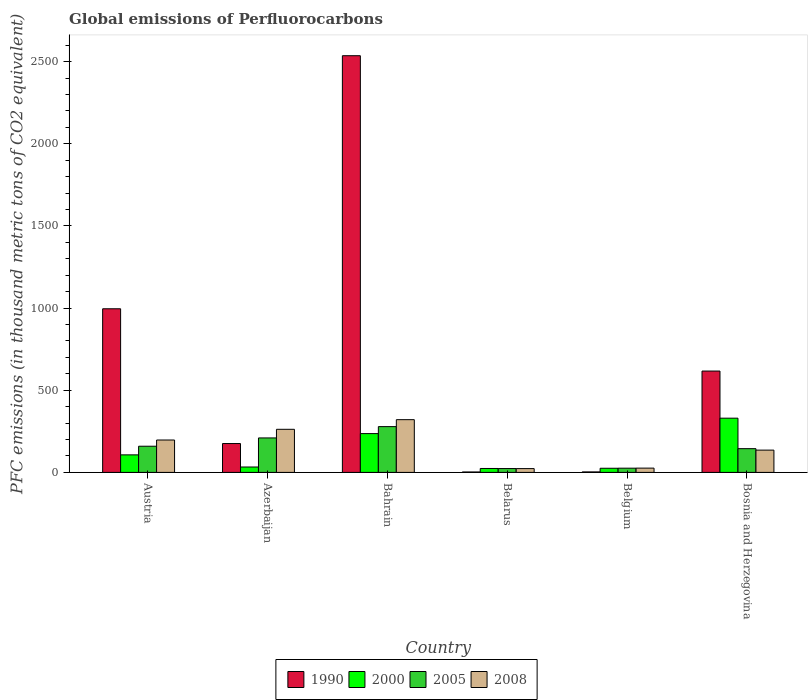How many different coloured bars are there?
Your answer should be compact. 4. How many groups of bars are there?
Offer a very short reply. 6. Are the number of bars per tick equal to the number of legend labels?
Your answer should be very brief. Yes. Are the number of bars on each tick of the X-axis equal?
Provide a short and direct response. Yes. How many bars are there on the 5th tick from the left?
Provide a short and direct response. 4. How many bars are there on the 1st tick from the right?
Ensure brevity in your answer.  4. What is the global emissions of Perfluorocarbons in 1990 in Azerbaijan?
Your answer should be compact. 175.6. Across all countries, what is the maximum global emissions of Perfluorocarbons in 1990?
Your response must be concise. 2535.7. Across all countries, what is the minimum global emissions of Perfluorocarbons in 2000?
Ensure brevity in your answer.  23.9. In which country was the global emissions of Perfluorocarbons in 1990 maximum?
Offer a very short reply. Bahrain. In which country was the global emissions of Perfluorocarbons in 1990 minimum?
Make the answer very short. Belarus. What is the total global emissions of Perfluorocarbons in 2005 in the graph?
Ensure brevity in your answer.  841.1. What is the difference between the global emissions of Perfluorocarbons in 2000 in Azerbaijan and that in Belarus?
Your answer should be compact. 8.9. What is the difference between the global emissions of Perfluorocarbons in 2008 in Belgium and the global emissions of Perfluorocarbons in 2005 in Azerbaijan?
Keep it short and to the point. -183.7. What is the average global emissions of Perfluorocarbons in 2005 per country?
Your answer should be very brief. 140.18. What is the difference between the global emissions of Perfluorocarbons of/in 2005 and global emissions of Perfluorocarbons of/in 1990 in Bosnia and Herzegovina?
Offer a terse response. -472.3. In how many countries, is the global emissions of Perfluorocarbons in 2005 greater than 1700 thousand metric tons?
Offer a very short reply. 0. What is the ratio of the global emissions of Perfluorocarbons in 2008 in Belarus to that in Belgium?
Give a very brief answer. 0.89. Is the global emissions of Perfluorocarbons in 2008 in Bahrain less than that in Belarus?
Ensure brevity in your answer.  No. What is the difference between the highest and the second highest global emissions of Perfluorocarbons in 2000?
Provide a short and direct response. 223.2. What is the difference between the highest and the lowest global emissions of Perfluorocarbons in 1990?
Your response must be concise. 2533.1. In how many countries, is the global emissions of Perfluorocarbons in 1990 greater than the average global emissions of Perfluorocarbons in 1990 taken over all countries?
Offer a terse response. 2. Is the sum of the global emissions of Perfluorocarbons in 2005 in Azerbaijan and Belgium greater than the maximum global emissions of Perfluorocarbons in 2008 across all countries?
Provide a short and direct response. No. Is it the case that in every country, the sum of the global emissions of Perfluorocarbons in 2008 and global emissions of Perfluorocarbons in 1990 is greater than the sum of global emissions of Perfluorocarbons in 2000 and global emissions of Perfluorocarbons in 2005?
Give a very brief answer. No. What does the 3rd bar from the left in Belgium represents?
Offer a very short reply. 2005. Are all the bars in the graph horizontal?
Your answer should be compact. No. What is the difference between two consecutive major ticks on the Y-axis?
Ensure brevity in your answer.  500. Are the values on the major ticks of Y-axis written in scientific E-notation?
Your answer should be compact. No. Does the graph contain grids?
Ensure brevity in your answer.  No. How many legend labels are there?
Your response must be concise. 4. How are the legend labels stacked?
Your answer should be very brief. Horizontal. What is the title of the graph?
Provide a short and direct response. Global emissions of Perfluorocarbons. Does "2013" appear as one of the legend labels in the graph?
Provide a succinct answer. No. What is the label or title of the Y-axis?
Ensure brevity in your answer.  PFC emissions (in thousand metric tons of CO2 equivalent). What is the PFC emissions (in thousand metric tons of CO2 equivalent) of 1990 in Austria?
Offer a terse response. 995.7. What is the PFC emissions (in thousand metric tons of CO2 equivalent) in 2000 in Austria?
Offer a very short reply. 106.7. What is the PFC emissions (in thousand metric tons of CO2 equivalent) of 2005 in Austria?
Provide a succinct answer. 159.3. What is the PFC emissions (in thousand metric tons of CO2 equivalent) in 2008 in Austria?
Your answer should be very brief. 197.1. What is the PFC emissions (in thousand metric tons of CO2 equivalent) of 1990 in Azerbaijan?
Provide a short and direct response. 175.6. What is the PFC emissions (in thousand metric tons of CO2 equivalent) of 2000 in Azerbaijan?
Keep it short and to the point. 32.8. What is the PFC emissions (in thousand metric tons of CO2 equivalent) of 2005 in Azerbaijan?
Offer a very short reply. 209.7. What is the PFC emissions (in thousand metric tons of CO2 equivalent) in 2008 in Azerbaijan?
Your answer should be very brief. 262.2. What is the PFC emissions (in thousand metric tons of CO2 equivalent) in 1990 in Bahrain?
Ensure brevity in your answer.  2535.7. What is the PFC emissions (in thousand metric tons of CO2 equivalent) in 2000 in Bahrain?
Keep it short and to the point. 236.1. What is the PFC emissions (in thousand metric tons of CO2 equivalent) in 2005 in Bahrain?
Give a very brief answer. 278.6. What is the PFC emissions (in thousand metric tons of CO2 equivalent) in 2008 in Bahrain?
Your answer should be compact. 320.9. What is the PFC emissions (in thousand metric tons of CO2 equivalent) of 1990 in Belarus?
Your response must be concise. 2.6. What is the PFC emissions (in thousand metric tons of CO2 equivalent) in 2000 in Belarus?
Your response must be concise. 23.9. What is the PFC emissions (in thousand metric tons of CO2 equivalent) of 2005 in Belarus?
Provide a succinct answer. 23.4. What is the PFC emissions (in thousand metric tons of CO2 equivalent) of 2008 in Belarus?
Your answer should be compact. 23.1. What is the PFC emissions (in thousand metric tons of CO2 equivalent) in 2000 in Belgium?
Your response must be concise. 25.2. What is the PFC emissions (in thousand metric tons of CO2 equivalent) in 2005 in Belgium?
Offer a terse response. 25.7. What is the PFC emissions (in thousand metric tons of CO2 equivalent) of 2008 in Belgium?
Offer a terse response. 26. What is the PFC emissions (in thousand metric tons of CO2 equivalent) in 1990 in Bosnia and Herzegovina?
Your response must be concise. 616.7. What is the PFC emissions (in thousand metric tons of CO2 equivalent) in 2000 in Bosnia and Herzegovina?
Keep it short and to the point. 329.9. What is the PFC emissions (in thousand metric tons of CO2 equivalent) of 2005 in Bosnia and Herzegovina?
Your response must be concise. 144.4. What is the PFC emissions (in thousand metric tons of CO2 equivalent) in 2008 in Bosnia and Herzegovina?
Make the answer very short. 135.6. Across all countries, what is the maximum PFC emissions (in thousand metric tons of CO2 equivalent) of 1990?
Ensure brevity in your answer.  2535.7. Across all countries, what is the maximum PFC emissions (in thousand metric tons of CO2 equivalent) of 2000?
Keep it short and to the point. 329.9. Across all countries, what is the maximum PFC emissions (in thousand metric tons of CO2 equivalent) of 2005?
Your answer should be very brief. 278.6. Across all countries, what is the maximum PFC emissions (in thousand metric tons of CO2 equivalent) of 2008?
Your answer should be very brief. 320.9. Across all countries, what is the minimum PFC emissions (in thousand metric tons of CO2 equivalent) of 2000?
Provide a succinct answer. 23.9. Across all countries, what is the minimum PFC emissions (in thousand metric tons of CO2 equivalent) of 2005?
Keep it short and to the point. 23.4. Across all countries, what is the minimum PFC emissions (in thousand metric tons of CO2 equivalent) of 2008?
Provide a short and direct response. 23.1. What is the total PFC emissions (in thousand metric tons of CO2 equivalent) of 1990 in the graph?
Ensure brevity in your answer.  4329.2. What is the total PFC emissions (in thousand metric tons of CO2 equivalent) of 2000 in the graph?
Provide a short and direct response. 754.6. What is the total PFC emissions (in thousand metric tons of CO2 equivalent) of 2005 in the graph?
Offer a terse response. 841.1. What is the total PFC emissions (in thousand metric tons of CO2 equivalent) of 2008 in the graph?
Offer a very short reply. 964.9. What is the difference between the PFC emissions (in thousand metric tons of CO2 equivalent) of 1990 in Austria and that in Azerbaijan?
Offer a terse response. 820.1. What is the difference between the PFC emissions (in thousand metric tons of CO2 equivalent) of 2000 in Austria and that in Azerbaijan?
Offer a very short reply. 73.9. What is the difference between the PFC emissions (in thousand metric tons of CO2 equivalent) of 2005 in Austria and that in Azerbaijan?
Your answer should be very brief. -50.4. What is the difference between the PFC emissions (in thousand metric tons of CO2 equivalent) in 2008 in Austria and that in Azerbaijan?
Give a very brief answer. -65.1. What is the difference between the PFC emissions (in thousand metric tons of CO2 equivalent) of 1990 in Austria and that in Bahrain?
Make the answer very short. -1540. What is the difference between the PFC emissions (in thousand metric tons of CO2 equivalent) of 2000 in Austria and that in Bahrain?
Provide a short and direct response. -129.4. What is the difference between the PFC emissions (in thousand metric tons of CO2 equivalent) in 2005 in Austria and that in Bahrain?
Give a very brief answer. -119.3. What is the difference between the PFC emissions (in thousand metric tons of CO2 equivalent) of 2008 in Austria and that in Bahrain?
Provide a short and direct response. -123.8. What is the difference between the PFC emissions (in thousand metric tons of CO2 equivalent) in 1990 in Austria and that in Belarus?
Your answer should be very brief. 993.1. What is the difference between the PFC emissions (in thousand metric tons of CO2 equivalent) of 2000 in Austria and that in Belarus?
Make the answer very short. 82.8. What is the difference between the PFC emissions (in thousand metric tons of CO2 equivalent) in 2005 in Austria and that in Belarus?
Offer a very short reply. 135.9. What is the difference between the PFC emissions (in thousand metric tons of CO2 equivalent) of 2008 in Austria and that in Belarus?
Ensure brevity in your answer.  174. What is the difference between the PFC emissions (in thousand metric tons of CO2 equivalent) of 1990 in Austria and that in Belgium?
Give a very brief answer. 992.8. What is the difference between the PFC emissions (in thousand metric tons of CO2 equivalent) in 2000 in Austria and that in Belgium?
Keep it short and to the point. 81.5. What is the difference between the PFC emissions (in thousand metric tons of CO2 equivalent) in 2005 in Austria and that in Belgium?
Your answer should be very brief. 133.6. What is the difference between the PFC emissions (in thousand metric tons of CO2 equivalent) in 2008 in Austria and that in Belgium?
Keep it short and to the point. 171.1. What is the difference between the PFC emissions (in thousand metric tons of CO2 equivalent) in 1990 in Austria and that in Bosnia and Herzegovina?
Offer a very short reply. 379. What is the difference between the PFC emissions (in thousand metric tons of CO2 equivalent) in 2000 in Austria and that in Bosnia and Herzegovina?
Make the answer very short. -223.2. What is the difference between the PFC emissions (in thousand metric tons of CO2 equivalent) of 2008 in Austria and that in Bosnia and Herzegovina?
Offer a very short reply. 61.5. What is the difference between the PFC emissions (in thousand metric tons of CO2 equivalent) of 1990 in Azerbaijan and that in Bahrain?
Provide a short and direct response. -2360.1. What is the difference between the PFC emissions (in thousand metric tons of CO2 equivalent) in 2000 in Azerbaijan and that in Bahrain?
Your response must be concise. -203.3. What is the difference between the PFC emissions (in thousand metric tons of CO2 equivalent) in 2005 in Azerbaijan and that in Bahrain?
Your answer should be very brief. -68.9. What is the difference between the PFC emissions (in thousand metric tons of CO2 equivalent) of 2008 in Azerbaijan and that in Bahrain?
Your answer should be compact. -58.7. What is the difference between the PFC emissions (in thousand metric tons of CO2 equivalent) in 1990 in Azerbaijan and that in Belarus?
Your answer should be very brief. 173. What is the difference between the PFC emissions (in thousand metric tons of CO2 equivalent) in 2000 in Azerbaijan and that in Belarus?
Offer a terse response. 8.9. What is the difference between the PFC emissions (in thousand metric tons of CO2 equivalent) of 2005 in Azerbaijan and that in Belarus?
Your answer should be compact. 186.3. What is the difference between the PFC emissions (in thousand metric tons of CO2 equivalent) of 2008 in Azerbaijan and that in Belarus?
Offer a very short reply. 239.1. What is the difference between the PFC emissions (in thousand metric tons of CO2 equivalent) in 1990 in Azerbaijan and that in Belgium?
Provide a succinct answer. 172.7. What is the difference between the PFC emissions (in thousand metric tons of CO2 equivalent) in 2005 in Azerbaijan and that in Belgium?
Your response must be concise. 184. What is the difference between the PFC emissions (in thousand metric tons of CO2 equivalent) in 2008 in Azerbaijan and that in Belgium?
Your response must be concise. 236.2. What is the difference between the PFC emissions (in thousand metric tons of CO2 equivalent) in 1990 in Azerbaijan and that in Bosnia and Herzegovina?
Your answer should be compact. -441.1. What is the difference between the PFC emissions (in thousand metric tons of CO2 equivalent) in 2000 in Azerbaijan and that in Bosnia and Herzegovina?
Keep it short and to the point. -297.1. What is the difference between the PFC emissions (in thousand metric tons of CO2 equivalent) of 2005 in Azerbaijan and that in Bosnia and Herzegovina?
Your answer should be very brief. 65.3. What is the difference between the PFC emissions (in thousand metric tons of CO2 equivalent) in 2008 in Azerbaijan and that in Bosnia and Herzegovina?
Offer a terse response. 126.6. What is the difference between the PFC emissions (in thousand metric tons of CO2 equivalent) of 1990 in Bahrain and that in Belarus?
Your response must be concise. 2533.1. What is the difference between the PFC emissions (in thousand metric tons of CO2 equivalent) of 2000 in Bahrain and that in Belarus?
Your answer should be compact. 212.2. What is the difference between the PFC emissions (in thousand metric tons of CO2 equivalent) of 2005 in Bahrain and that in Belarus?
Offer a very short reply. 255.2. What is the difference between the PFC emissions (in thousand metric tons of CO2 equivalent) in 2008 in Bahrain and that in Belarus?
Your response must be concise. 297.8. What is the difference between the PFC emissions (in thousand metric tons of CO2 equivalent) of 1990 in Bahrain and that in Belgium?
Offer a terse response. 2532.8. What is the difference between the PFC emissions (in thousand metric tons of CO2 equivalent) in 2000 in Bahrain and that in Belgium?
Offer a terse response. 210.9. What is the difference between the PFC emissions (in thousand metric tons of CO2 equivalent) in 2005 in Bahrain and that in Belgium?
Keep it short and to the point. 252.9. What is the difference between the PFC emissions (in thousand metric tons of CO2 equivalent) in 2008 in Bahrain and that in Belgium?
Give a very brief answer. 294.9. What is the difference between the PFC emissions (in thousand metric tons of CO2 equivalent) of 1990 in Bahrain and that in Bosnia and Herzegovina?
Your response must be concise. 1919. What is the difference between the PFC emissions (in thousand metric tons of CO2 equivalent) of 2000 in Bahrain and that in Bosnia and Herzegovina?
Make the answer very short. -93.8. What is the difference between the PFC emissions (in thousand metric tons of CO2 equivalent) in 2005 in Bahrain and that in Bosnia and Herzegovina?
Offer a terse response. 134.2. What is the difference between the PFC emissions (in thousand metric tons of CO2 equivalent) of 2008 in Bahrain and that in Bosnia and Herzegovina?
Provide a succinct answer. 185.3. What is the difference between the PFC emissions (in thousand metric tons of CO2 equivalent) of 1990 in Belarus and that in Belgium?
Provide a succinct answer. -0.3. What is the difference between the PFC emissions (in thousand metric tons of CO2 equivalent) of 2000 in Belarus and that in Belgium?
Your answer should be very brief. -1.3. What is the difference between the PFC emissions (in thousand metric tons of CO2 equivalent) of 2008 in Belarus and that in Belgium?
Ensure brevity in your answer.  -2.9. What is the difference between the PFC emissions (in thousand metric tons of CO2 equivalent) of 1990 in Belarus and that in Bosnia and Herzegovina?
Your answer should be compact. -614.1. What is the difference between the PFC emissions (in thousand metric tons of CO2 equivalent) of 2000 in Belarus and that in Bosnia and Herzegovina?
Provide a short and direct response. -306. What is the difference between the PFC emissions (in thousand metric tons of CO2 equivalent) in 2005 in Belarus and that in Bosnia and Herzegovina?
Provide a short and direct response. -121. What is the difference between the PFC emissions (in thousand metric tons of CO2 equivalent) in 2008 in Belarus and that in Bosnia and Herzegovina?
Provide a succinct answer. -112.5. What is the difference between the PFC emissions (in thousand metric tons of CO2 equivalent) in 1990 in Belgium and that in Bosnia and Herzegovina?
Keep it short and to the point. -613.8. What is the difference between the PFC emissions (in thousand metric tons of CO2 equivalent) of 2000 in Belgium and that in Bosnia and Herzegovina?
Provide a succinct answer. -304.7. What is the difference between the PFC emissions (in thousand metric tons of CO2 equivalent) in 2005 in Belgium and that in Bosnia and Herzegovina?
Ensure brevity in your answer.  -118.7. What is the difference between the PFC emissions (in thousand metric tons of CO2 equivalent) in 2008 in Belgium and that in Bosnia and Herzegovina?
Give a very brief answer. -109.6. What is the difference between the PFC emissions (in thousand metric tons of CO2 equivalent) in 1990 in Austria and the PFC emissions (in thousand metric tons of CO2 equivalent) in 2000 in Azerbaijan?
Offer a very short reply. 962.9. What is the difference between the PFC emissions (in thousand metric tons of CO2 equivalent) in 1990 in Austria and the PFC emissions (in thousand metric tons of CO2 equivalent) in 2005 in Azerbaijan?
Ensure brevity in your answer.  786. What is the difference between the PFC emissions (in thousand metric tons of CO2 equivalent) of 1990 in Austria and the PFC emissions (in thousand metric tons of CO2 equivalent) of 2008 in Azerbaijan?
Ensure brevity in your answer.  733.5. What is the difference between the PFC emissions (in thousand metric tons of CO2 equivalent) of 2000 in Austria and the PFC emissions (in thousand metric tons of CO2 equivalent) of 2005 in Azerbaijan?
Your answer should be very brief. -103. What is the difference between the PFC emissions (in thousand metric tons of CO2 equivalent) in 2000 in Austria and the PFC emissions (in thousand metric tons of CO2 equivalent) in 2008 in Azerbaijan?
Provide a short and direct response. -155.5. What is the difference between the PFC emissions (in thousand metric tons of CO2 equivalent) of 2005 in Austria and the PFC emissions (in thousand metric tons of CO2 equivalent) of 2008 in Azerbaijan?
Make the answer very short. -102.9. What is the difference between the PFC emissions (in thousand metric tons of CO2 equivalent) of 1990 in Austria and the PFC emissions (in thousand metric tons of CO2 equivalent) of 2000 in Bahrain?
Keep it short and to the point. 759.6. What is the difference between the PFC emissions (in thousand metric tons of CO2 equivalent) of 1990 in Austria and the PFC emissions (in thousand metric tons of CO2 equivalent) of 2005 in Bahrain?
Ensure brevity in your answer.  717.1. What is the difference between the PFC emissions (in thousand metric tons of CO2 equivalent) of 1990 in Austria and the PFC emissions (in thousand metric tons of CO2 equivalent) of 2008 in Bahrain?
Provide a short and direct response. 674.8. What is the difference between the PFC emissions (in thousand metric tons of CO2 equivalent) of 2000 in Austria and the PFC emissions (in thousand metric tons of CO2 equivalent) of 2005 in Bahrain?
Provide a succinct answer. -171.9. What is the difference between the PFC emissions (in thousand metric tons of CO2 equivalent) in 2000 in Austria and the PFC emissions (in thousand metric tons of CO2 equivalent) in 2008 in Bahrain?
Your response must be concise. -214.2. What is the difference between the PFC emissions (in thousand metric tons of CO2 equivalent) in 2005 in Austria and the PFC emissions (in thousand metric tons of CO2 equivalent) in 2008 in Bahrain?
Provide a short and direct response. -161.6. What is the difference between the PFC emissions (in thousand metric tons of CO2 equivalent) of 1990 in Austria and the PFC emissions (in thousand metric tons of CO2 equivalent) of 2000 in Belarus?
Offer a terse response. 971.8. What is the difference between the PFC emissions (in thousand metric tons of CO2 equivalent) in 1990 in Austria and the PFC emissions (in thousand metric tons of CO2 equivalent) in 2005 in Belarus?
Your answer should be very brief. 972.3. What is the difference between the PFC emissions (in thousand metric tons of CO2 equivalent) of 1990 in Austria and the PFC emissions (in thousand metric tons of CO2 equivalent) of 2008 in Belarus?
Keep it short and to the point. 972.6. What is the difference between the PFC emissions (in thousand metric tons of CO2 equivalent) in 2000 in Austria and the PFC emissions (in thousand metric tons of CO2 equivalent) in 2005 in Belarus?
Ensure brevity in your answer.  83.3. What is the difference between the PFC emissions (in thousand metric tons of CO2 equivalent) in 2000 in Austria and the PFC emissions (in thousand metric tons of CO2 equivalent) in 2008 in Belarus?
Give a very brief answer. 83.6. What is the difference between the PFC emissions (in thousand metric tons of CO2 equivalent) of 2005 in Austria and the PFC emissions (in thousand metric tons of CO2 equivalent) of 2008 in Belarus?
Your answer should be compact. 136.2. What is the difference between the PFC emissions (in thousand metric tons of CO2 equivalent) in 1990 in Austria and the PFC emissions (in thousand metric tons of CO2 equivalent) in 2000 in Belgium?
Your response must be concise. 970.5. What is the difference between the PFC emissions (in thousand metric tons of CO2 equivalent) of 1990 in Austria and the PFC emissions (in thousand metric tons of CO2 equivalent) of 2005 in Belgium?
Offer a very short reply. 970. What is the difference between the PFC emissions (in thousand metric tons of CO2 equivalent) in 1990 in Austria and the PFC emissions (in thousand metric tons of CO2 equivalent) in 2008 in Belgium?
Offer a terse response. 969.7. What is the difference between the PFC emissions (in thousand metric tons of CO2 equivalent) in 2000 in Austria and the PFC emissions (in thousand metric tons of CO2 equivalent) in 2008 in Belgium?
Offer a very short reply. 80.7. What is the difference between the PFC emissions (in thousand metric tons of CO2 equivalent) of 2005 in Austria and the PFC emissions (in thousand metric tons of CO2 equivalent) of 2008 in Belgium?
Keep it short and to the point. 133.3. What is the difference between the PFC emissions (in thousand metric tons of CO2 equivalent) in 1990 in Austria and the PFC emissions (in thousand metric tons of CO2 equivalent) in 2000 in Bosnia and Herzegovina?
Provide a succinct answer. 665.8. What is the difference between the PFC emissions (in thousand metric tons of CO2 equivalent) in 1990 in Austria and the PFC emissions (in thousand metric tons of CO2 equivalent) in 2005 in Bosnia and Herzegovina?
Ensure brevity in your answer.  851.3. What is the difference between the PFC emissions (in thousand metric tons of CO2 equivalent) of 1990 in Austria and the PFC emissions (in thousand metric tons of CO2 equivalent) of 2008 in Bosnia and Herzegovina?
Offer a very short reply. 860.1. What is the difference between the PFC emissions (in thousand metric tons of CO2 equivalent) in 2000 in Austria and the PFC emissions (in thousand metric tons of CO2 equivalent) in 2005 in Bosnia and Herzegovina?
Provide a short and direct response. -37.7. What is the difference between the PFC emissions (in thousand metric tons of CO2 equivalent) of 2000 in Austria and the PFC emissions (in thousand metric tons of CO2 equivalent) of 2008 in Bosnia and Herzegovina?
Offer a terse response. -28.9. What is the difference between the PFC emissions (in thousand metric tons of CO2 equivalent) in 2005 in Austria and the PFC emissions (in thousand metric tons of CO2 equivalent) in 2008 in Bosnia and Herzegovina?
Ensure brevity in your answer.  23.7. What is the difference between the PFC emissions (in thousand metric tons of CO2 equivalent) of 1990 in Azerbaijan and the PFC emissions (in thousand metric tons of CO2 equivalent) of 2000 in Bahrain?
Make the answer very short. -60.5. What is the difference between the PFC emissions (in thousand metric tons of CO2 equivalent) of 1990 in Azerbaijan and the PFC emissions (in thousand metric tons of CO2 equivalent) of 2005 in Bahrain?
Your answer should be compact. -103. What is the difference between the PFC emissions (in thousand metric tons of CO2 equivalent) of 1990 in Azerbaijan and the PFC emissions (in thousand metric tons of CO2 equivalent) of 2008 in Bahrain?
Your answer should be very brief. -145.3. What is the difference between the PFC emissions (in thousand metric tons of CO2 equivalent) in 2000 in Azerbaijan and the PFC emissions (in thousand metric tons of CO2 equivalent) in 2005 in Bahrain?
Keep it short and to the point. -245.8. What is the difference between the PFC emissions (in thousand metric tons of CO2 equivalent) of 2000 in Azerbaijan and the PFC emissions (in thousand metric tons of CO2 equivalent) of 2008 in Bahrain?
Provide a succinct answer. -288.1. What is the difference between the PFC emissions (in thousand metric tons of CO2 equivalent) of 2005 in Azerbaijan and the PFC emissions (in thousand metric tons of CO2 equivalent) of 2008 in Bahrain?
Your response must be concise. -111.2. What is the difference between the PFC emissions (in thousand metric tons of CO2 equivalent) of 1990 in Azerbaijan and the PFC emissions (in thousand metric tons of CO2 equivalent) of 2000 in Belarus?
Keep it short and to the point. 151.7. What is the difference between the PFC emissions (in thousand metric tons of CO2 equivalent) of 1990 in Azerbaijan and the PFC emissions (in thousand metric tons of CO2 equivalent) of 2005 in Belarus?
Offer a terse response. 152.2. What is the difference between the PFC emissions (in thousand metric tons of CO2 equivalent) in 1990 in Azerbaijan and the PFC emissions (in thousand metric tons of CO2 equivalent) in 2008 in Belarus?
Give a very brief answer. 152.5. What is the difference between the PFC emissions (in thousand metric tons of CO2 equivalent) of 2000 in Azerbaijan and the PFC emissions (in thousand metric tons of CO2 equivalent) of 2008 in Belarus?
Your answer should be very brief. 9.7. What is the difference between the PFC emissions (in thousand metric tons of CO2 equivalent) of 2005 in Azerbaijan and the PFC emissions (in thousand metric tons of CO2 equivalent) of 2008 in Belarus?
Provide a succinct answer. 186.6. What is the difference between the PFC emissions (in thousand metric tons of CO2 equivalent) in 1990 in Azerbaijan and the PFC emissions (in thousand metric tons of CO2 equivalent) in 2000 in Belgium?
Make the answer very short. 150.4. What is the difference between the PFC emissions (in thousand metric tons of CO2 equivalent) of 1990 in Azerbaijan and the PFC emissions (in thousand metric tons of CO2 equivalent) of 2005 in Belgium?
Provide a succinct answer. 149.9. What is the difference between the PFC emissions (in thousand metric tons of CO2 equivalent) of 1990 in Azerbaijan and the PFC emissions (in thousand metric tons of CO2 equivalent) of 2008 in Belgium?
Give a very brief answer. 149.6. What is the difference between the PFC emissions (in thousand metric tons of CO2 equivalent) of 2000 in Azerbaijan and the PFC emissions (in thousand metric tons of CO2 equivalent) of 2005 in Belgium?
Give a very brief answer. 7.1. What is the difference between the PFC emissions (in thousand metric tons of CO2 equivalent) in 2000 in Azerbaijan and the PFC emissions (in thousand metric tons of CO2 equivalent) in 2008 in Belgium?
Offer a very short reply. 6.8. What is the difference between the PFC emissions (in thousand metric tons of CO2 equivalent) of 2005 in Azerbaijan and the PFC emissions (in thousand metric tons of CO2 equivalent) of 2008 in Belgium?
Ensure brevity in your answer.  183.7. What is the difference between the PFC emissions (in thousand metric tons of CO2 equivalent) of 1990 in Azerbaijan and the PFC emissions (in thousand metric tons of CO2 equivalent) of 2000 in Bosnia and Herzegovina?
Provide a short and direct response. -154.3. What is the difference between the PFC emissions (in thousand metric tons of CO2 equivalent) in 1990 in Azerbaijan and the PFC emissions (in thousand metric tons of CO2 equivalent) in 2005 in Bosnia and Herzegovina?
Keep it short and to the point. 31.2. What is the difference between the PFC emissions (in thousand metric tons of CO2 equivalent) in 2000 in Azerbaijan and the PFC emissions (in thousand metric tons of CO2 equivalent) in 2005 in Bosnia and Herzegovina?
Keep it short and to the point. -111.6. What is the difference between the PFC emissions (in thousand metric tons of CO2 equivalent) in 2000 in Azerbaijan and the PFC emissions (in thousand metric tons of CO2 equivalent) in 2008 in Bosnia and Herzegovina?
Keep it short and to the point. -102.8. What is the difference between the PFC emissions (in thousand metric tons of CO2 equivalent) in 2005 in Azerbaijan and the PFC emissions (in thousand metric tons of CO2 equivalent) in 2008 in Bosnia and Herzegovina?
Ensure brevity in your answer.  74.1. What is the difference between the PFC emissions (in thousand metric tons of CO2 equivalent) of 1990 in Bahrain and the PFC emissions (in thousand metric tons of CO2 equivalent) of 2000 in Belarus?
Your answer should be compact. 2511.8. What is the difference between the PFC emissions (in thousand metric tons of CO2 equivalent) of 1990 in Bahrain and the PFC emissions (in thousand metric tons of CO2 equivalent) of 2005 in Belarus?
Your answer should be compact. 2512.3. What is the difference between the PFC emissions (in thousand metric tons of CO2 equivalent) of 1990 in Bahrain and the PFC emissions (in thousand metric tons of CO2 equivalent) of 2008 in Belarus?
Provide a succinct answer. 2512.6. What is the difference between the PFC emissions (in thousand metric tons of CO2 equivalent) of 2000 in Bahrain and the PFC emissions (in thousand metric tons of CO2 equivalent) of 2005 in Belarus?
Your answer should be compact. 212.7. What is the difference between the PFC emissions (in thousand metric tons of CO2 equivalent) of 2000 in Bahrain and the PFC emissions (in thousand metric tons of CO2 equivalent) of 2008 in Belarus?
Your response must be concise. 213. What is the difference between the PFC emissions (in thousand metric tons of CO2 equivalent) of 2005 in Bahrain and the PFC emissions (in thousand metric tons of CO2 equivalent) of 2008 in Belarus?
Your response must be concise. 255.5. What is the difference between the PFC emissions (in thousand metric tons of CO2 equivalent) in 1990 in Bahrain and the PFC emissions (in thousand metric tons of CO2 equivalent) in 2000 in Belgium?
Your response must be concise. 2510.5. What is the difference between the PFC emissions (in thousand metric tons of CO2 equivalent) of 1990 in Bahrain and the PFC emissions (in thousand metric tons of CO2 equivalent) of 2005 in Belgium?
Offer a very short reply. 2510. What is the difference between the PFC emissions (in thousand metric tons of CO2 equivalent) of 1990 in Bahrain and the PFC emissions (in thousand metric tons of CO2 equivalent) of 2008 in Belgium?
Offer a very short reply. 2509.7. What is the difference between the PFC emissions (in thousand metric tons of CO2 equivalent) of 2000 in Bahrain and the PFC emissions (in thousand metric tons of CO2 equivalent) of 2005 in Belgium?
Ensure brevity in your answer.  210.4. What is the difference between the PFC emissions (in thousand metric tons of CO2 equivalent) in 2000 in Bahrain and the PFC emissions (in thousand metric tons of CO2 equivalent) in 2008 in Belgium?
Provide a short and direct response. 210.1. What is the difference between the PFC emissions (in thousand metric tons of CO2 equivalent) of 2005 in Bahrain and the PFC emissions (in thousand metric tons of CO2 equivalent) of 2008 in Belgium?
Offer a terse response. 252.6. What is the difference between the PFC emissions (in thousand metric tons of CO2 equivalent) in 1990 in Bahrain and the PFC emissions (in thousand metric tons of CO2 equivalent) in 2000 in Bosnia and Herzegovina?
Give a very brief answer. 2205.8. What is the difference between the PFC emissions (in thousand metric tons of CO2 equivalent) of 1990 in Bahrain and the PFC emissions (in thousand metric tons of CO2 equivalent) of 2005 in Bosnia and Herzegovina?
Provide a short and direct response. 2391.3. What is the difference between the PFC emissions (in thousand metric tons of CO2 equivalent) of 1990 in Bahrain and the PFC emissions (in thousand metric tons of CO2 equivalent) of 2008 in Bosnia and Herzegovina?
Give a very brief answer. 2400.1. What is the difference between the PFC emissions (in thousand metric tons of CO2 equivalent) in 2000 in Bahrain and the PFC emissions (in thousand metric tons of CO2 equivalent) in 2005 in Bosnia and Herzegovina?
Your answer should be compact. 91.7. What is the difference between the PFC emissions (in thousand metric tons of CO2 equivalent) of 2000 in Bahrain and the PFC emissions (in thousand metric tons of CO2 equivalent) of 2008 in Bosnia and Herzegovina?
Give a very brief answer. 100.5. What is the difference between the PFC emissions (in thousand metric tons of CO2 equivalent) in 2005 in Bahrain and the PFC emissions (in thousand metric tons of CO2 equivalent) in 2008 in Bosnia and Herzegovina?
Your answer should be very brief. 143. What is the difference between the PFC emissions (in thousand metric tons of CO2 equivalent) of 1990 in Belarus and the PFC emissions (in thousand metric tons of CO2 equivalent) of 2000 in Belgium?
Give a very brief answer. -22.6. What is the difference between the PFC emissions (in thousand metric tons of CO2 equivalent) in 1990 in Belarus and the PFC emissions (in thousand metric tons of CO2 equivalent) in 2005 in Belgium?
Your answer should be very brief. -23.1. What is the difference between the PFC emissions (in thousand metric tons of CO2 equivalent) of 1990 in Belarus and the PFC emissions (in thousand metric tons of CO2 equivalent) of 2008 in Belgium?
Your answer should be very brief. -23.4. What is the difference between the PFC emissions (in thousand metric tons of CO2 equivalent) in 2000 in Belarus and the PFC emissions (in thousand metric tons of CO2 equivalent) in 2008 in Belgium?
Offer a terse response. -2.1. What is the difference between the PFC emissions (in thousand metric tons of CO2 equivalent) of 1990 in Belarus and the PFC emissions (in thousand metric tons of CO2 equivalent) of 2000 in Bosnia and Herzegovina?
Keep it short and to the point. -327.3. What is the difference between the PFC emissions (in thousand metric tons of CO2 equivalent) in 1990 in Belarus and the PFC emissions (in thousand metric tons of CO2 equivalent) in 2005 in Bosnia and Herzegovina?
Provide a short and direct response. -141.8. What is the difference between the PFC emissions (in thousand metric tons of CO2 equivalent) of 1990 in Belarus and the PFC emissions (in thousand metric tons of CO2 equivalent) of 2008 in Bosnia and Herzegovina?
Give a very brief answer. -133. What is the difference between the PFC emissions (in thousand metric tons of CO2 equivalent) of 2000 in Belarus and the PFC emissions (in thousand metric tons of CO2 equivalent) of 2005 in Bosnia and Herzegovina?
Ensure brevity in your answer.  -120.5. What is the difference between the PFC emissions (in thousand metric tons of CO2 equivalent) in 2000 in Belarus and the PFC emissions (in thousand metric tons of CO2 equivalent) in 2008 in Bosnia and Herzegovina?
Provide a short and direct response. -111.7. What is the difference between the PFC emissions (in thousand metric tons of CO2 equivalent) of 2005 in Belarus and the PFC emissions (in thousand metric tons of CO2 equivalent) of 2008 in Bosnia and Herzegovina?
Provide a succinct answer. -112.2. What is the difference between the PFC emissions (in thousand metric tons of CO2 equivalent) of 1990 in Belgium and the PFC emissions (in thousand metric tons of CO2 equivalent) of 2000 in Bosnia and Herzegovina?
Offer a terse response. -327. What is the difference between the PFC emissions (in thousand metric tons of CO2 equivalent) of 1990 in Belgium and the PFC emissions (in thousand metric tons of CO2 equivalent) of 2005 in Bosnia and Herzegovina?
Provide a succinct answer. -141.5. What is the difference between the PFC emissions (in thousand metric tons of CO2 equivalent) in 1990 in Belgium and the PFC emissions (in thousand metric tons of CO2 equivalent) in 2008 in Bosnia and Herzegovina?
Make the answer very short. -132.7. What is the difference between the PFC emissions (in thousand metric tons of CO2 equivalent) in 2000 in Belgium and the PFC emissions (in thousand metric tons of CO2 equivalent) in 2005 in Bosnia and Herzegovina?
Ensure brevity in your answer.  -119.2. What is the difference between the PFC emissions (in thousand metric tons of CO2 equivalent) in 2000 in Belgium and the PFC emissions (in thousand metric tons of CO2 equivalent) in 2008 in Bosnia and Herzegovina?
Your response must be concise. -110.4. What is the difference between the PFC emissions (in thousand metric tons of CO2 equivalent) in 2005 in Belgium and the PFC emissions (in thousand metric tons of CO2 equivalent) in 2008 in Bosnia and Herzegovina?
Your answer should be very brief. -109.9. What is the average PFC emissions (in thousand metric tons of CO2 equivalent) of 1990 per country?
Give a very brief answer. 721.53. What is the average PFC emissions (in thousand metric tons of CO2 equivalent) in 2000 per country?
Offer a terse response. 125.77. What is the average PFC emissions (in thousand metric tons of CO2 equivalent) in 2005 per country?
Give a very brief answer. 140.18. What is the average PFC emissions (in thousand metric tons of CO2 equivalent) in 2008 per country?
Ensure brevity in your answer.  160.82. What is the difference between the PFC emissions (in thousand metric tons of CO2 equivalent) in 1990 and PFC emissions (in thousand metric tons of CO2 equivalent) in 2000 in Austria?
Offer a very short reply. 889. What is the difference between the PFC emissions (in thousand metric tons of CO2 equivalent) in 1990 and PFC emissions (in thousand metric tons of CO2 equivalent) in 2005 in Austria?
Your response must be concise. 836.4. What is the difference between the PFC emissions (in thousand metric tons of CO2 equivalent) in 1990 and PFC emissions (in thousand metric tons of CO2 equivalent) in 2008 in Austria?
Give a very brief answer. 798.6. What is the difference between the PFC emissions (in thousand metric tons of CO2 equivalent) in 2000 and PFC emissions (in thousand metric tons of CO2 equivalent) in 2005 in Austria?
Offer a terse response. -52.6. What is the difference between the PFC emissions (in thousand metric tons of CO2 equivalent) in 2000 and PFC emissions (in thousand metric tons of CO2 equivalent) in 2008 in Austria?
Ensure brevity in your answer.  -90.4. What is the difference between the PFC emissions (in thousand metric tons of CO2 equivalent) of 2005 and PFC emissions (in thousand metric tons of CO2 equivalent) of 2008 in Austria?
Provide a succinct answer. -37.8. What is the difference between the PFC emissions (in thousand metric tons of CO2 equivalent) in 1990 and PFC emissions (in thousand metric tons of CO2 equivalent) in 2000 in Azerbaijan?
Your answer should be compact. 142.8. What is the difference between the PFC emissions (in thousand metric tons of CO2 equivalent) of 1990 and PFC emissions (in thousand metric tons of CO2 equivalent) of 2005 in Azerbaijan?
Your answer should be compact. -34.1. What is the difference between the PFC emissions (in thousand metric tons of CO2 equivalent) of 1990 and PFC emissions (in thousand metric tons of CO2 equivalent) of 2008 in Azerbaijan?
Ensure brevity in your answer.  -86.6. What is the difference between the PFC emissions (in thousand metric tons of CO2 equivalent) of 2000 and PFC emissions (in thousand metric tons of CO2 equivalent) of 2005 in Azerbaijan?
Make the answer very short. -176.9. What is the difference between the PFC emissions (in thousand metric tons of CO2 equivalent) in 2000 and PFC emissions (in thousand metric tons of CO2 equivalent) in 2008 in Azerbaijan?
Ensure brevity in your answer.  -229.4. What is the difference between the PFC emissions (in thousand metric tons of CO2 equivalent) in 2005 and PFC emissions (in thousand metric tons of CO2 equivalent) in 2008 in Azerbaijan?
Offer a terse response. -52.5. What is the difference between the PFC emissions (in thousand metric tons of CO2 equivalent) of 1990 and PFC emissions (in thousand metric tons of CO2 equivalent) of 2000 in Bahrain?
Make the answer very short. 2299.6. What is the difference between the PFC emissions (in thousand metric tons of CO2 equivalent) in 1990 and PFC emissions (in thousand metric tons of CO2 equivalent) in 2005 in Bahrain?
Your answer should be compact. 2257.1. What is the difference between the PFC emissions (in thousand metric tons of CO2 equivalent) in 1990 and PFC emissions (in thousand metric tons of CO2 equivalent) in 2008 in Bahrain?
Your response must be concise. 2214.8. What is the difference between the PFC emissions (in thousand metric tons of CO2 equivalent) in 2000 and PFC emissions (in thousand metric tons of CO2 equivalent) in 2005 in Bahrain?
Your response must be concise. -42.5. What is the difference between the PFC emissions (in thousand metric tons of CO2 equivalent) of 2000 and PFC emissions (in thousand metric tons of CO2 equivalent) of 2008 in Bahrain?
Make the answer very short. -84.8. What is the difference between the PFC emissions (in thousand metric tons of CO2 equivalent) of 2005 and PFC emissions (in thousand metric tons of CO2 equivalent) of 2008 in Bahrain?
Your answer should be compact. -42.3. What is the difference between the PFC emissions (in thousand metric tons of CO2 equivalent) of 1990 and PFC emissions (in thousand metric tons of CO2 equivalent) of 2000 in Belarus?
Your answer should be very brief. -21.3. What is the difference between the PFC emissions (in thousand metric tons of CO2 equivalent) in 1990 and PFC emissions (in thousand metric tons of CO2 equivalent) in 2005 in Belarus?
Offer a terse response. -20.8. What is the difference between the PFC emissions (in thousand metric tons of CO2 equivalent) of 1990 and PFC emissions (in thousand metric tons of CO2 equivalent) of 2008 in Belarus?
Provide a succinct answer. -20.5. What is the difference between the PFC emissions (in thousand metric tons of CO2 equivalent) in 2005 and PFC emissions (in thousand metric tons of CO2 equivalent) in 2008 in Belarus?
Provide a short and direct response. 0.3. What is the difference between the PFC emissions (in thousand metric tons of CO2 equivalent) of 1990 and PFC emissions (in thousand metric tons of CO2 equivalent) of 2000 in Belgium?
Your response must be concise. -22.3. What is the difference between the PFC emissions (in thousand metric tons of CO2 equivalent) of 1990 and PFC emissions (in thousand metric tons of CO2 equivalent) of 2005 in Belgium?
Give a very brief answer. -22.8. What is the difference between the PFC emissions (in thousand metric tons of CO2 equivalent) of 1990 and PFC emissions (in thousand metric tons of CO2 equivalent) of 2008 in Belgium?
Provide a succinct answer. -23.1. What is the difference between the PFC emissions (in thousand metric tons of CO2 equivalent) of 2000 and PFC emissions (in thousand metric tons of CO2 equivalent) of 2008 in Belgium?
Keep it short and to the point. -0.8. What is the difference between the PFC emissions (in thousand metric tons of CO2 equivalent) in 2005 and PFC emissions (in thousand metric tons of CO2 equivalent) in 2008 in Belgium?
Offer a very short reply. -0.3. What is the difference between the PFC emissions (in thousand metric tons of CO2 equivalent) of 1990 and PFC emissions (in thousand metric tons of CO2 equivalent) of 2000 in Bosnia and Herzegovina?
Offer a terse response. 286.8. What is the difference between the PFC emissions (in thousand metric tons of CO2 equivalent) in 1990 and PFC emissions (in thousand metric tons of CO2 equivalent) in 2005 in Bosnia and Herzegovina?
Give a very brief answer. 472.3. What is the difference between the PFC emissions (in thousand metric tons of CO2 equivalent) of 1990 and PFC emissions (in thousand metric tons of CO2 equivalent) of 2008 in Bosnia and Herzegovina?
Provide a short and direct response. 481.1. What is the difference between the PFC emissions (in thousand metric tons of CO2 equivalent) in 2000 and PFC emissions (in thousand metric tons of CO2 equivalent) in 2005 in Bosnia and Herzegovina?
Provide a succinct answer. 185.5. What is the difference between the PFC emissions (in thousand metric tons of CO2 equivalent) of 2000 and PFC emissions (in thousand metric tons of CO2 equivalent) of 2008 in Bosnia and Herzegovina?
Provide a succinct answer. 194.3. What is the difference between the PFC emissions (in thousand metric tons of CO2 equivalent) in 2005 and PFC emissions (in thousand metric tons of CO2 equivalent) in 2008 in Bosnia and Herzegovina?
Your answer should be very brief. 8.8. What is the ratio of the PFC emissions (in thousand metric tons of CO2 equivalent) in 1990 in Austria to that in Azerbaijan?
Your answer should be compact. 5.67. What is the ratio of the PFC emissions (in thousand metric tons of CO2 equivalent) in 2000 in Austria to that in Azerbaijan?
Provide a succinct answer. 3.25. What is the ratio of the PFC emissions (in thousand metric tons of CO2 equivalent) of 2005 in Austria to that in Azerbaijan?
Provide a short and direct response. 0.76. What is the ratio of the PFC emissions (in thousand metric tons of CO2 equivalent) of 2008 in Austria to that in Azerbaijan?
Keep it short and to the point. 0.75. What is the ratio of the PFC emissions (in thousand metric tons of CO2 equivalent) in 1990 in Austria to that in Bahrain?
Your response must be concise. 0.39. What is the ratio of the PFC emissions (in thousand metric tons of CO2 equivalent) of 2000 in Austria to that in Bahrain?
Your response must be concise. 0.45. What is the ratio of the PFC emissions (in thousand metric tons of CO2 equivalent) of 2005 in Austria to that in Bahrain?
Offer a terse response. 0.57. What is the ratio of the PFC emissions (in thousand metric tons of CO2 equivalent) in 2008 in Austria to that in Bahrain?
Your answer should be very brief. 0.61. What is the ratio of the PFC emissions (in thousand metric tons of CO2 equivalent) in 1990 in Austria to that in Belarus?
Give a very brief answer. 382.96. What is the ratio of the PFC emissions (in thousand metric tons of CO2 equivalent) in 2000 in Austria to that in Belarus?
Keep it short and to the point. 4.46. What is the ratio of the PFC emissions (in thousand metric tons of CO2 equivalent) of 2005 in Austria to that in Belarus?
Provide a short and direct response. 6.81. What is the ratio of the PFC emissions (in thousand metric tons of CO2 equivalent) of 2008 in Austria to that in Belarus?
Provide a succinct answer. 8.53. What is the ratio of the PFC emissions (in thousand metric tons of CO2 equivalent) in 1990 in Austria to that in Belgium?
Your response must be concise. 343.34. What is the ratio of the PFC emissions (in thousand metric tons of CO2 equivalent) of 2000 in Austria to that in Belgium?
Provide a succinct answer. 4.23. What is the ratio of the PFC emissions (in thousand metric tons of CO2 equivalent) of 2005 in Austria to that in Belgium?
Your response must be concise. 6.2. What is the ratio of the PFC emissions (in thousand metric tons of CO2 equivalent) of 2008 in Austria to that in Belgium?
Keep it short and to the point. 7.58. What is the ratio of the PFC emissions (in thousand metric tons of CO2 equivalent) in 1990 in Austria to that in Bosnia and Herzegovina?
Make the answer very short. 1.61. What is the ratio of the PFC emissions (in thousand metric tons of CO2 equivalent) of 2000 in Austria to that in Bosnia and Herzegovina?
Your answer should be very brief. 0.32. What is the ratio of the PFC emissions (in thousand metric tons of CO2 equivalent) of 2005 in Austria to that in Bosnia and Herzegovina?
Provide a short and direct response. 1.1. What is the ratio of the PFC emissions (in thousand metric tons of CO2 equivalent) of 2008 in Austria to that in Bosnia and Herzegovina?
Keep it short and to the point. 1.45. What is the ratio of the PFC emissions (in thousand metric tons of CO2 equivalent) in 1990 in Azerbaijan to that in Bahrain?
Keep it short and to the point. 0.07. What is the ratio of the PFC emissions (in thousand metric tons of CO2 equivalent) in 2000 in Azerbaijan to that in Bahrain?
Your answer should be very brief. 0.14. What is the ratio of the PFC emissions (in thousand metric tons of CO2 equivalent) of 2005 in Azerbaijan to that in Bahrain?
Ensure brevity in your answer.  0.75. What is the ratio of the PFC emissions (in thousand metric tons of CO2 equivalent) in 2008 in Azerbaijan to that in Bahrain?
Offer a terse response. 0.82. What is the ratio of the PFC emissions (in thousand metric tons of CO2 equivalent) of 1990 in Azerbaijan to that in Belarus?
Offer a very short reply. 67.54. What is the ratio of the PFC emissions (in thousand metric tons of CO2 equivalent) of 2000 in Azerbaijan to that in Belarus?
Provide a succinct answer. 1.37. What is the ratio of the PFC emissions (in thousand metric tons of CO2 equivalent) in 2005 in Azerbaijan to that in Belarus?
Offer a very short reply. 8.96. What is the ratio of the PFC emissions (in thousand metric tons of CO2 equivalent) in 2008 in Azerbaijan to that in Belarus?
Provide a succinct answer. 11.35. What is the ratio of the PFC emissions (in thousand metric tons of CO2 equivalent) of 1990 in Azerbaijan to that in Belgium?
Give a very brief answer. 60.55. What is the ratio of the PFC emissions (in thousand metric tons of CO2 equivalent) of 2000 in Azerbaijan to that in Belgium?
Give a very brief answer. 1.3. What is the ratio of the PFC emissions (in thousand metric tons of CO2 equivalent) in 2005 in Azerbaijan to that in Belgium?
Your response must be concise. 8.16. What is the ratio of the PFC emissions (in thousand metric tons of CO2 equivalent) of 2008 in Azerbaijan to that in Belgium?
Provide a short and direct response. 10.08. What is the ratio of the PFC emissions (in thousand metric tons of CO2 equivalent) of 1990 in Azerbaijan to that in Bosnia and Herzegovina?
Ensure brevity in your answer.  0.28. What is the ratio of the PFC emissions (in thousand metric tons of CO2 equivalent) in 2000 in Azerbaijan to that in Bosnia and Herzegovina?
Make the answer very short. 0.1. What is the ratio of the PFC emissions (in thousand metric tons of CO2 equivalent) of 2005 in Azerbaijan to that in Bosnia and Herzegovina?
Ensure brevity in your answer.  1.45. What is the ratio of the PFC emissions (in thousand metric tons of CO2 equivalent) of 2008 in Azerbaijan to that in Bosnia and Herzegovina?
Keep it short and to the point. 1.93. What is the ratio of the PFC emissions (in thousand metric tons of CO2 equivalent) in 1990 in Bahrain to that in Belarus?
Make the answer very short. 975.27. What is the ratio of the PFC emissions (in thousand metric tons of CO2 equivalent) of 2000 in Bahrain to that in Belarus?
Provide a succinct answer. 9.88. What is the ratio of the PFC emissions (in thousand metric tons of CO2 equivalent) in 2005 in Bahrain to that in Belarus?
Your answer should be very brief. 11.91. What is the ratio of the PFC emissions (in thousand metric tons of CO2 equivalent) of 2008 in Bahrain to that in Belarus?
Provide a short and direct response. 13.89. What is the ratio of the PFC emissions (in thousand metric tons of CO2 equivalent) in 1990 in Bahrain to that in Belgium?
Your response must be concise. 874.38. What is the ratio of the PFC emissions (in thousand metric tons of CO2 equivalent) of 2000 in Bahrain to that in Belgium?
Your response must be concise. 9.37. What is the ratio of the PFC emissions (in thousand metric tons of CO2 equivalent) of 2005 in Bahrain to that in Belgium?
Give a very brief answer. 10.84. What is the ratio of the PFC emissions (in thousand metric tons of CO2 equivalent) in 2008 in Bahrain to that in Belgium?
Your answer should be very brief. 12.34. What is the ratio of the PFC emissions (in thousand metric tons of CO2 equivalent) in 1990 in Bahrain to that in Bosnia and Herzegovina?
Make the answer very short. 4.11. What is the ratio of the PFC emissions (in thousand metric tons of CO2 equivalent) of 2000 in Bahrain to that in Bosnia and Herzegovina?
Offer a terse response. 0.72. What is the ratio of the PFC emissions (in thousand metric tons of CO2 equivalent) of 2005 in Bahrain to that in Bosnia and Herzegovina?
Give a very brief answer. 1.93. What is the ratio of the PFC emissions (in thousand metric tons of CO2 equivalent) in 2008 in Bahrain to that in Bosnia and Herzegovina?
Your response must be concise. 2.37. What is the ratio of the PFC emissions (in thousand metric tons of CO2 equivalent) in 1990 in Belarus to that in Belgium?
Your answer should be very brief. 0.9. What is the ratio of the PFC emissions (in thousand metric tons of CO2 equivalent) of 2000 in Belarus to that in Belgium?
Provide a short and direct response. 0.95. What is the ratio of the PFC emissions (in thousand metric tons of CO2 equivalent) of 2005 in Belarus to that in Belgium?
Keep it short and to the point. 0.91. What is the ratio of the PFC emissions (in thousand metric tons of CO2 equivalent) in 2008 in Belarus to that in Belgium?
Ensure brevity in your answer.  0.89. What is the ratio of the PFC emissions (in thousand metric tons of CO2 equivalent) in 1990 in Belarus to that in Bosnia and Herzegovina?
Keep it short and to the point. 0. What is the ratio of the PFC emissions (in thousand metric tons of CO2 equivalent) in 2000 in Belarus to that in Bosnia and Herzegovina?
Your answer should be compact. 0.07. What is the ratio of the PFC emissions (in thousand metric tons of CO2 equivalent) of 2005 in Belarus to that in Bosnia and Herzegovina?
Offer a terse response. 0.16. What is the ratio of the PFC emissions (in thousand metric tons of CO2 equivalent) of 2008 in Belarus to that in Bosnia and Herzegovina?
Your answer should be very brief. 0.17. What is the ratio of the PFC emissions (in thousand metric tons of CO2 equivalent) in 1990 in Belgium to that in Bosnia and Herzegovina?
Offer a terse response. 0. What is the ratio of the PFC emissions (in thousand metric tons of CO2 equivalent) in 2000 in Belgium to that in Bosnia and Herzegovina?
Keep it short and to the point. 0.08. What is the ratio of the PFC emissions (in thousand metric tons of CO2 equivalent) of 2005 in Belgium to that in Bosnia and Herzegovina?
Ensure brevity in your answer.  0.18. What is the ratio of the PFC emissions (in thousand metric tons of CO2 equivalent) in 2008 in Belgium to that in Bosnia and Herzegovina?
Keep it short and to the point. 0.19. What is the difference between the highest and the second highest PFC emissions (in thousand metric tons of CO2 equivalent) of 1990?
Your answer should be compact. 1540. What is the difference between the highest and the second highest PFC emissions (in thousand metric tons of CO2 equivalent) in 2000?
Your answer should be very brief. 93.8. What is the difference between the highest and the second highest PFC emissions (in thousand metric tons of CO2 equivalent) in 2005?
Provide a succinct answer. 68.9. What is the difference between the highest and the second highest PFC emissions (in thousand metric tons of CO2 equivalent) in 2008?
Give a very brief answer. 58.7. What is the difference between the highest and the lowest PFC emissions (in thousand metric tons of CO2 equivalent) in 1990?
Provide a succinct answer. 2533.1. What is the difference between the highest and the lowest PFC emissions (in thousand metric tons of CO2 equivalent) in 2000?
Make the answer very short. 306. What is the difference between the highest and the lowest PFC emissions (in thousand metric tons of CO2 equivalent) of 2005?
Your response must be concise. 255.2. What is the difference between the highest and the lowest PFC emissions (in thousand metric tons of CO2 equivalent) in 2008?
Make the answer very short. 297.8. 